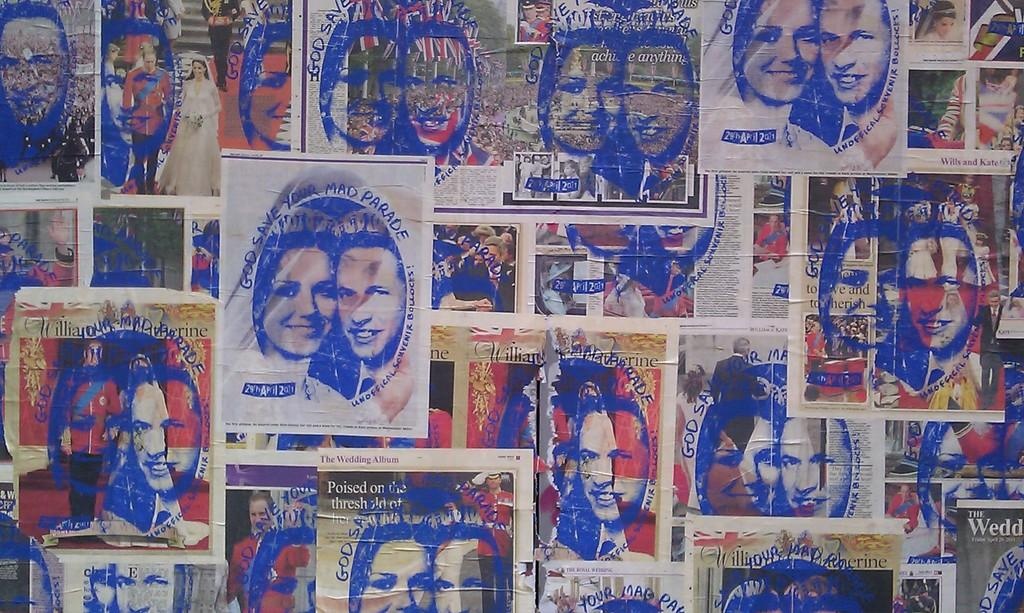What is located in the center of the image? There are posters in the center of the image. What type of images can be seen on the posters? The posters contain images of people. What else is featured on the posters besides the images? There is text on the posters. Can you tell me how many zephyrs are depicted on the posters? There are no zephyrs depicted on the posters; they contain images of people and text. What type of star is shown interacting with the people on the posters? There is no star shown interacting with the people on the posters; only images of people and text are present. 